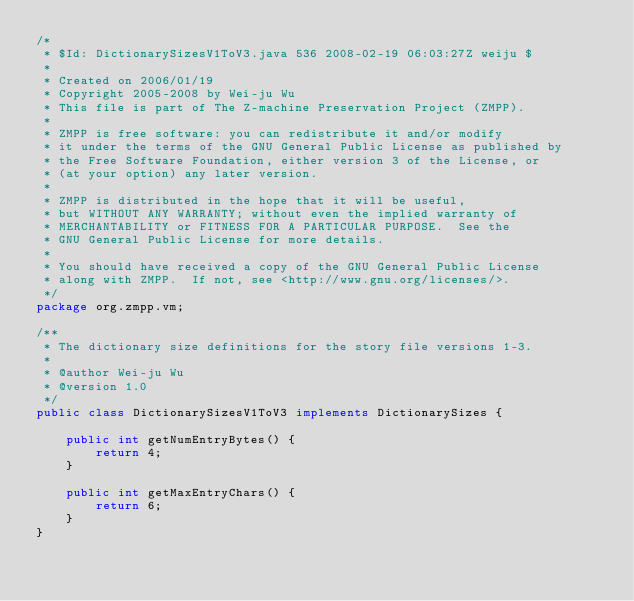<code> <loc_0><loc_0><loc_500><loc_500><_Java_>/*
 * $Id: DictionarySizesV1ToV3.java 536 2008-02-19 06:03:27Z weiju $
 * 
 * Created on 2006/01/19
 * Copyright 2005-2008 by Wei-ju Wu
 * This file is part of The Z-machine Preservation Project (ZMPP).
 *
 * ZMPP is free software: you can redistribute it and/or modify
 * it under the terms of the GNU General Public License as published by
 * the Free Software Foundation, either version 3 of the License, or
 * (at your option) any later version.
 *
 * ZMPP is distributed in the hope that it will be useful,
 * but WITHOUT ANY WARRANTY; without even the implied warranty of
 * MERCHANTABILITY or FITNESS FOR A PARTICULAR PURPOSE.  See the
 * GNU General Public License for more details.
 *
 * You should have received a copy of the GNU General Public License
 * along with ZMPP.  If not, see <http://www.gnu.org/licenses/>.
 */
package org.zmpp.vm;

/**
 * The dictionary size definitions for the story file versions 1-3.
 *
 * @author Wei-ju Wu
 * @version 1.0
 */
public class DictionarySizesV1ToV3 implements DictionarySizes {

    public int getNumEntryBytes() {
        return 4;
    }

    public int getMaxEntryChars() {
        return 6;
    }
}
</code> 